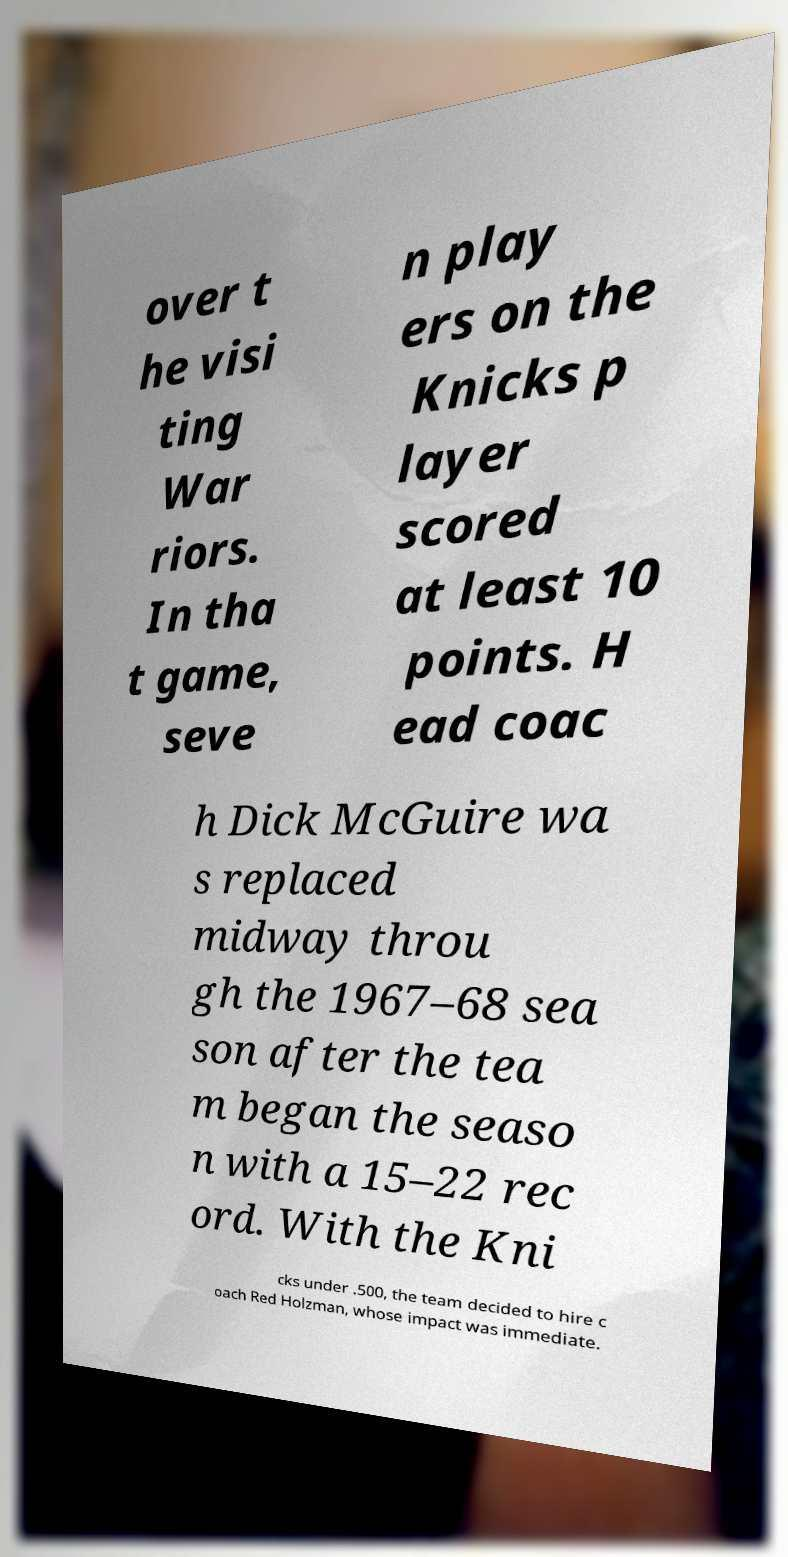Can you read and provide the text displayed in the image?This photo seems to have some interesting text. Can you extract and type it out for me? over t he visi ting War riors. In tha t game, seve n play ers on the Knicks p layer scored at least 10 points. H ead coac h Dick McGuire wa s replaced midway throu gh the 1967–68 sea son after the tea m began the seaso n with a 15–22 rec ord. With the Kni cks under .500, the team decided to hire c oach Red Holzman, whose impact was immediate. 